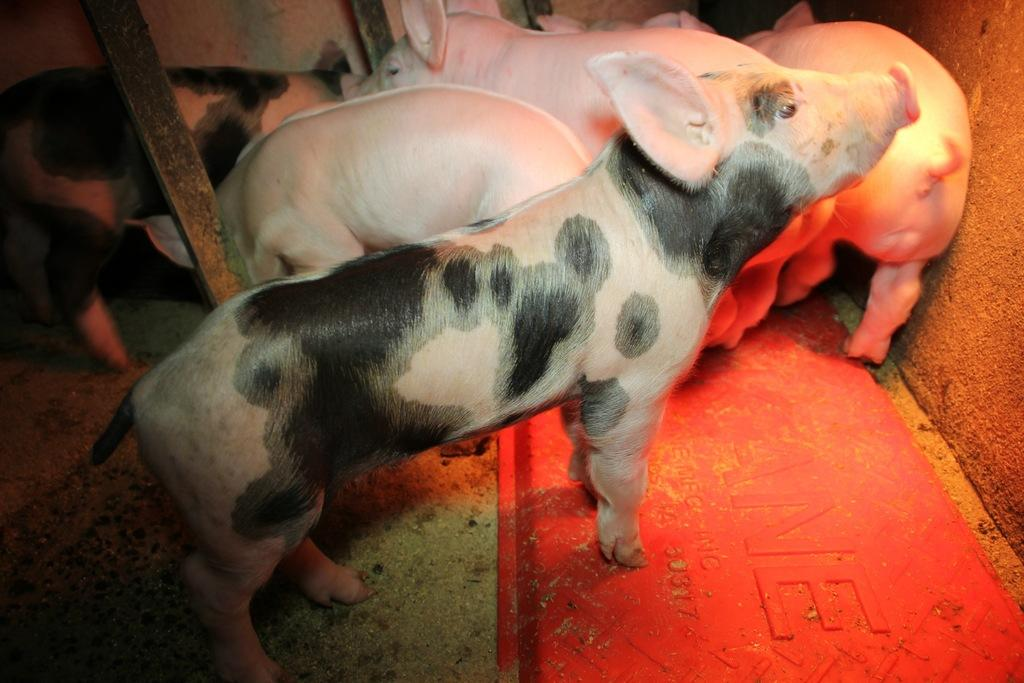What type of animals are in the image? There are pigs in the image. What colors are the pigs? Some pigs are pink in color, and some are pink and black in color. What is visible in the background of the image? There is a wall in the background of the image. What type of doctor can be seen treating the pigs in the image? There is no doctor present in the image; it only features pigs of different colors. What type of horn is visible on the pigs in the image? There are no horns visible on the pigs in the image. 